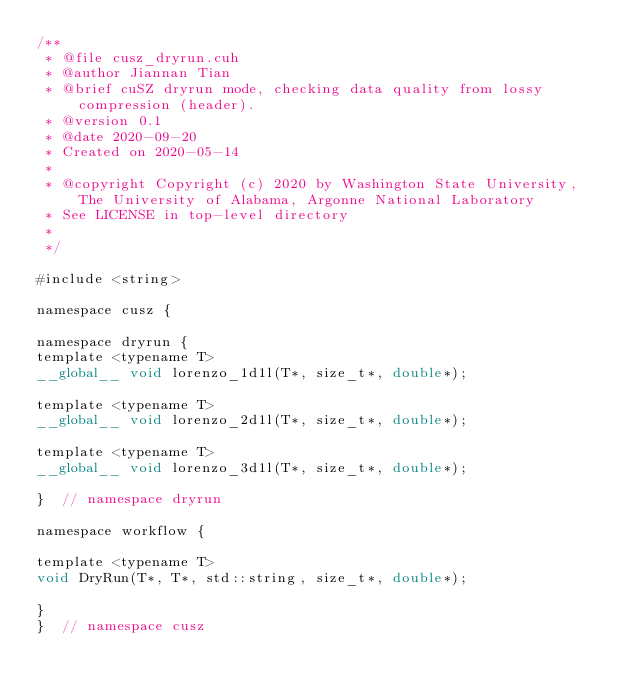Convert code to text. <code><loc_0><loc_0><loc_500><loc_500><_Cuda_>/**
 * @file cusz_dryrun.cuh
 * @author Jiannan Tian
 * @brief cuSZ dryrun mode, checking data quality from lossy compression (header).
 * @version 0.1
 * @date 2020-09-20
 * Created on 2020-05-14
 *
 * @copyright Copyright (c) 2020 by Washington State University, The University of Alabama, Argonne National Laboratory
 * See LICENSE in top-level directory
 *
 */

#include <string>

namespace cusz {

namespace dryrun {
template <typename T>
__global__ void lorenzo_1d1l(T*, size_t*, double*);

template <typename T>
__global__ void lorenzo_2d1l(T*, size_t*, double*);

template <typename T>
__global__ void lorenzo_3d1l(T*, size_t*, double*);

}  // namespace dryrun

namespace workflow {

template <typename T>
void DryRun(T*, T*, std::string, size_t*, double*);

}
}  // namespace cusz
</code> 